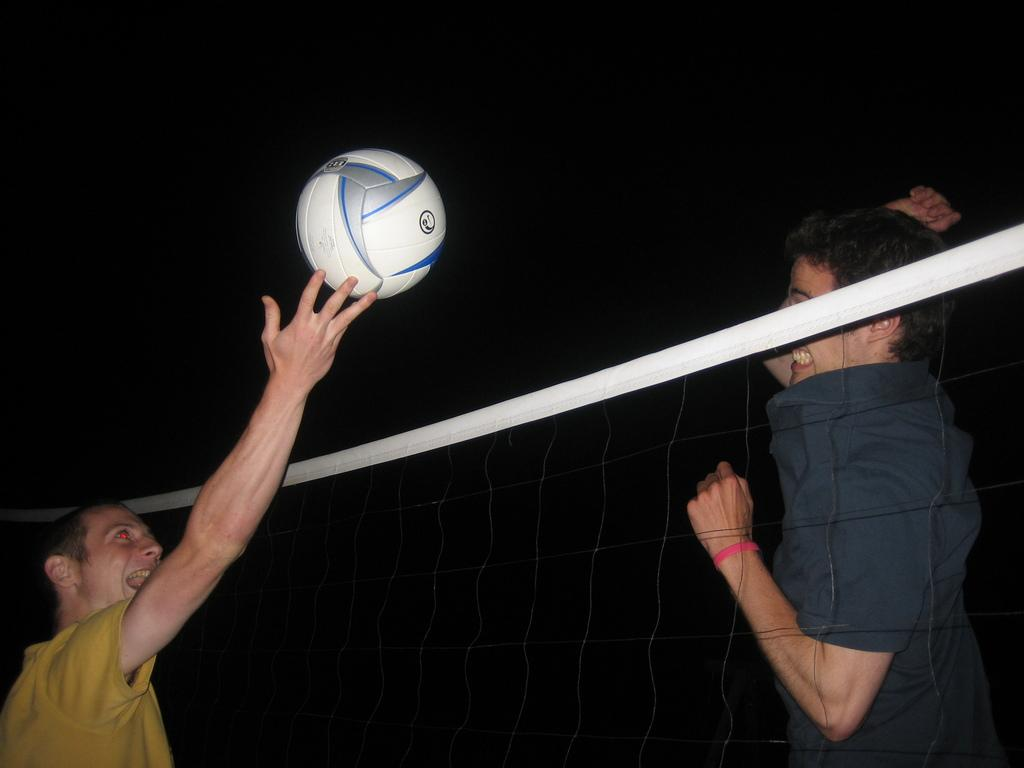How many people are in the image? There are two persons in the image. What activity are the two persons engaged in? The two persons are playing volleyball. What separates the two players in the game? There is a net between the two persons. When was the image captured? The image was captured at night. Can you see the moon in the image? The image does not show the moon; it features two people playing volleyball at night. Is there a dock visible in the image? There is no dock present in the image. 